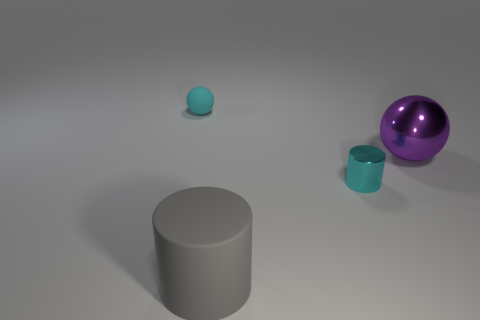Does the large gray rubber object have the same shape as the tiny cyan matte thing? no 